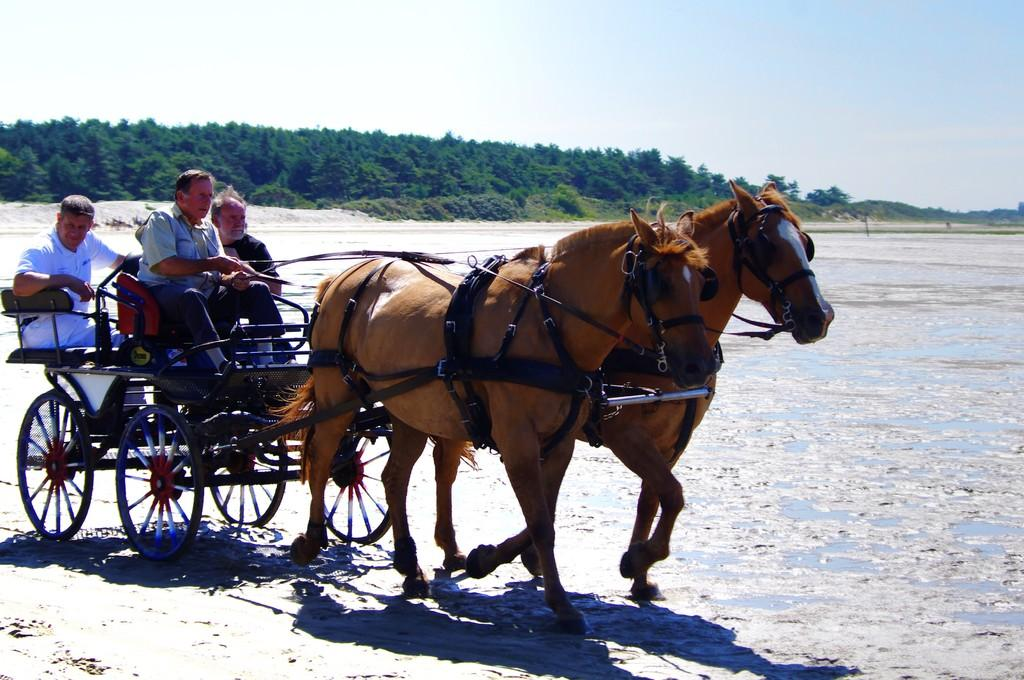What animals are present in the image? There are horses in the image. What else can be seen in the image besides the horses? There is a trolley with men sitting on it in the image. What type of vegetation is visible in the background of the image? Trees are visible in the background of the image. What is the condition of the sky in the image? The sky is clear in the image. What type of caption is written on the horses in the image? There is no caption written on the horses in the image. Can you tell me the condition of the drawer in the image? There is no drawer present in the image. 